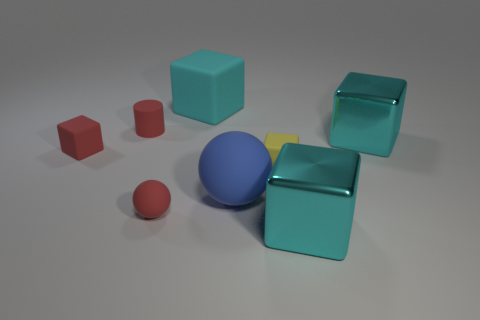There is a big cyan block that is in front of the red matte thing in front of the blue rubber sphere; what is it made of?
Keep it short and to the point. Metal. Are there any large balls that have the same color as the tiny rubber cylinder?
Your answer should be compact. No. Does the cube that is to the left of the red matte cylinder have the same size as the small red sphere?
Provide a short and direct response. Yes. Is the number of red balls that are right of the blue rubber ball the same as the number of tiny gray metal cubes?
Provide a succinct answer. Yes. How many objects are big cyan things behind the small red cylinder or tiny blue metallic objects?
Provide a short and direct response. 1. What shape is the small red object that is both behind the large sphere and in front of the red cylinder?
Your response must be concise. Cube. What number of things are red matte objects to the left of the rubber cylinder or rubber things that are on the left side of the small cylinder?
Ensure brevity in your answer.  1. What number of other things are the same size as the red rubber ball?
Ensure brevity in your answer.  3. There is a matte block left of the large matte cube; is its color the same as the rubber cylinder?
Provide a short and direct response. Yes. What size is the rubber cube that is both on the left side of the big blue thing and to the right of the red matte cylinder?
Ensure brevity in your answer.  Large. 